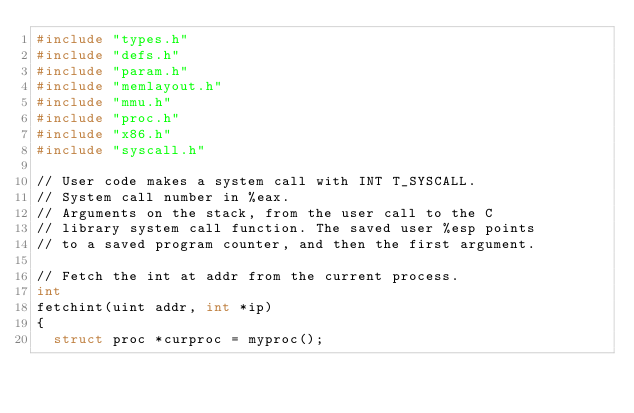<code> <loc_0><loc_0><loc_500><loc_500><_C_>#include "types.h"
#include "defs.h"
#include "param.h"
#include "memlayout.h"
#include "mmu.h"
#include "proc.h"
#include "x86.h"
#include "syscall.h"

// User code makes a system call with INT T_SYSCALL.
// System call number in %eax.
// Arguments on the stack, from the user call to the C
// library system call function. The saved user %esp points
// to a saved program counter, and then the first argument.

// Fetch the int at addr from the current process.
int
fetchint(uint addr, int *ip)
{
  struct proc *curproc = myproc();
</code> 